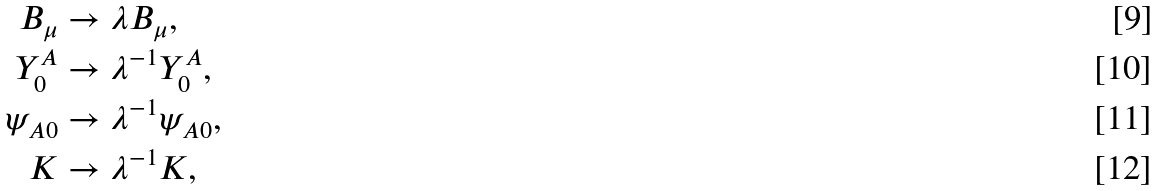Convert formula to latex. <formula><loc_0><loc_0><loc_500><loc_500>B _ { \mu } & \rightarrow \lambda B _ { \mu } , \\ Y ^ { A } _ { 0 } & \rightarrow \lambda ^ { - 1 } Y ^ { A } _ { 0 } , \\ \psi _ { A 0 } & \rightarrow \lambda ^ { - 1 } \psi _ { A 0 } , \\ K & \rightarrow \lambda ^ { - 1 } K ,</formula> 